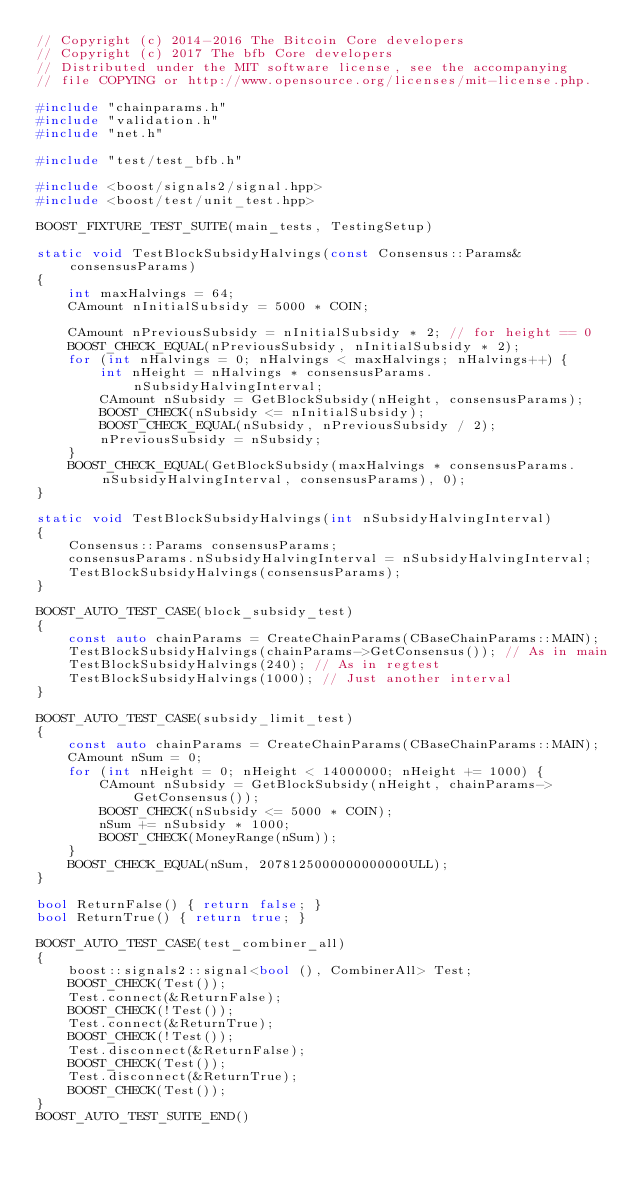Convert code to text. <code><loc_0><loc_0><loc_500><loc_500><_C++_>// Copyright (c) 2014-2016 The Bitcoin Core developers
// Copyright (c) 2017 The bfb Core developers
// Distributed under the MIT software license, see the accompanying
// file COPYING or http://www.opensource.org/licenses/mit-license.php.

#include "chainparams.h"
#include "validation.h"
#include "net.h"

#include "test/test_bfb.h"

#include <boost/signals2/signal.hpp>
#include <boost/test/unit_test.hpp>

BOOST_FIXTURE_TEST_SUITE(main_tests, TestingSetup)

static void TestBlockSubsidyHalvings(const Consensus::Params& consensusParams)
{
    int maxHalvings = 64;
    CAmount nInitialSubsidy = 5000 * COIN;

    CAmount nPreviousSubsidy = nInitialSubsidy * 2; // for height == 0
    BOOST_CHECK_EQUAL(nPreviousSubsidy, nInitialSubsidy * 2);
    for (int nHalvings = 0; nHalvings < maxHalvings; nHalvings++) {
        int nHeight = nHalvings * consensusParams.nSubsidyHalvingInterval;
        CAmount nSubsidy = GetBlockSubsidy(nHeight, consensusParams);
        BOOST_CHECK(nSubsidy <= nInitialSubsidy);
        BOOST_CHECK_EQUAL(nSubsidy, nPreviousSubsidy / 2);
        nPreviousSubsidy = nSubsidy;
    }
    BOOST_CHECK_EQUAL(GetBlockSubsidy(maxHalvings * consensusParams.nSubsidyHalvingInterval, consensusParams), 0);
}

static void TestBlockSubsidyHalvings(int nSubsidyHalvingInterval)
{
    Consensus::Params consensusParams;
    consensusParams.nSubsidyHalvingInterval = nSubsidyHalvingInterval;
    TestBlockSubsidyHalvings(consensusParams);
}

BOOST_AUTO_TEST_CASE(block_subsidy_test)
{
    const auto chainParams = CreateChainParams(CBaseChainParams::MAIN);
    TestBlockSubsidyHalvings(chainParams->GetConsensus()); // As in main
    TestBlockSubsidyHalvings(240); // As in regtest
    TestBlockSubsidyHalvings(1000); // Just another interval
}

BOOST_AUTO_TEST_CASE(subsidy_limit_test)
{
    const auto chainParams = CreateChainParams(CBaseChainParams::MAIN);
    CAmount nSum = 0;
    for (int nHeight = 0; nHeight < 14000000; nHeight += 1000) {
        CAmount nSubsidy = GetBlockSubsidy(nHeight, chainParams->GetConsensus());
        BOOST_CHECK(nSubsidy <= 5000 * COIN);
        nSum += nSubsidy * 1000;
        BOOST_CHECK(MoneyRange(nSum));
    }
    BOOST_CHECK_EQUAL(nSum, 2078125000000000000ULL);
}

bool ReturnFalse() { return false; }
bool ReturnTrue() { return true; }

BOOST_AUTO_TEST_CASE(test_combiner_all)
{
    boost::signals2::signal<bool (), CombinerAll> Test;
    BOOST_CHECK(Test());
    Test.connect(&ReturnFalse);
    BOOST_CHECK(!Test());
    Test.connect(&ReturnTrue);
    BOOST_CHECK(!Test());
    Test.disconnect(&ReturnFalse);
    BOOST_CHECK(Test());
    Test.disconnect(&ReturnTrue);
    BOOST_CHECK(Test());
}
BOOST_AUTO_TEST_SUITE_END()
</code> 